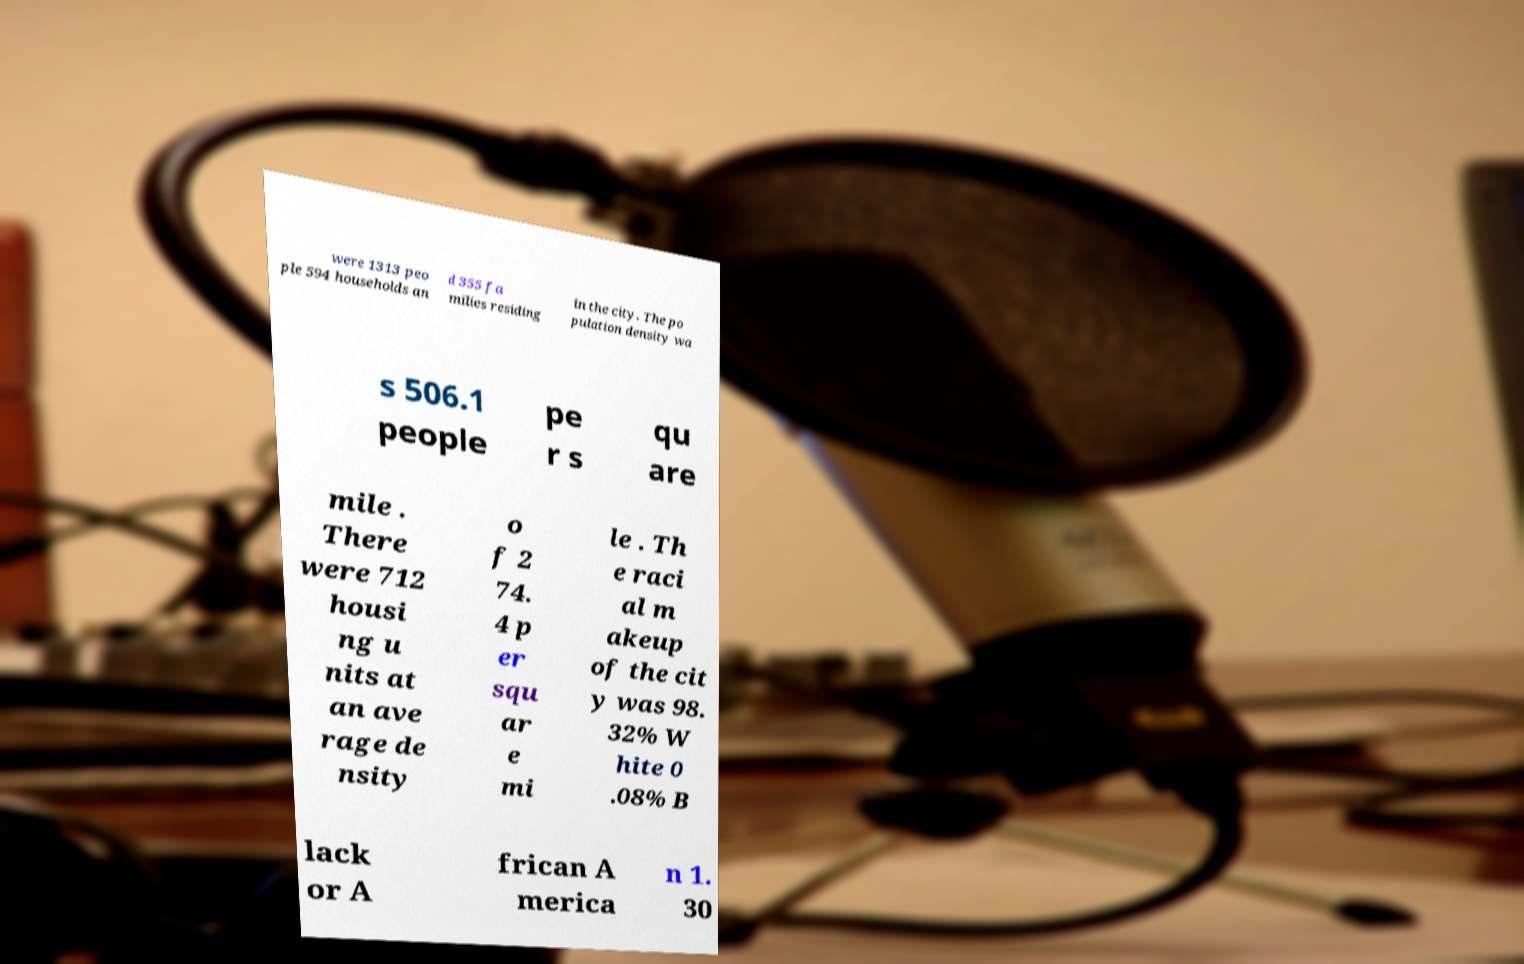For documentation purposes, I need the text within this image transcribed. Could you provide that? were 1313 peo ple 594 households an d 355 fa milies residing in the city. The po pulation density wa s 506.1 people pe r s qu are mile . There were 712 housi ng u nits at an ave rage de nsity o f 2 74. 4 p er squ ar e mi le . Th e raci al m akeup of the cit y was 98. 32% W hite 0 .08% B lack or A frican A merica n 1. 30 